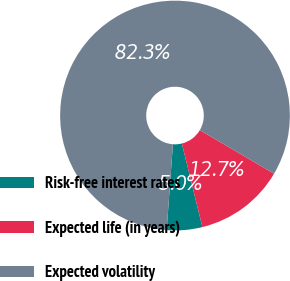Convert chart to OTSL. <chart><loc_0><loc_0><loc_500><loc_500><pie_chart><fcel>Risk-free interest rates<fcel>Expected life (in years)<fcel>Expected volatility<nl><fcel>4.99%<fcel>12.72%<fcel>82.29%<nl></chart> 